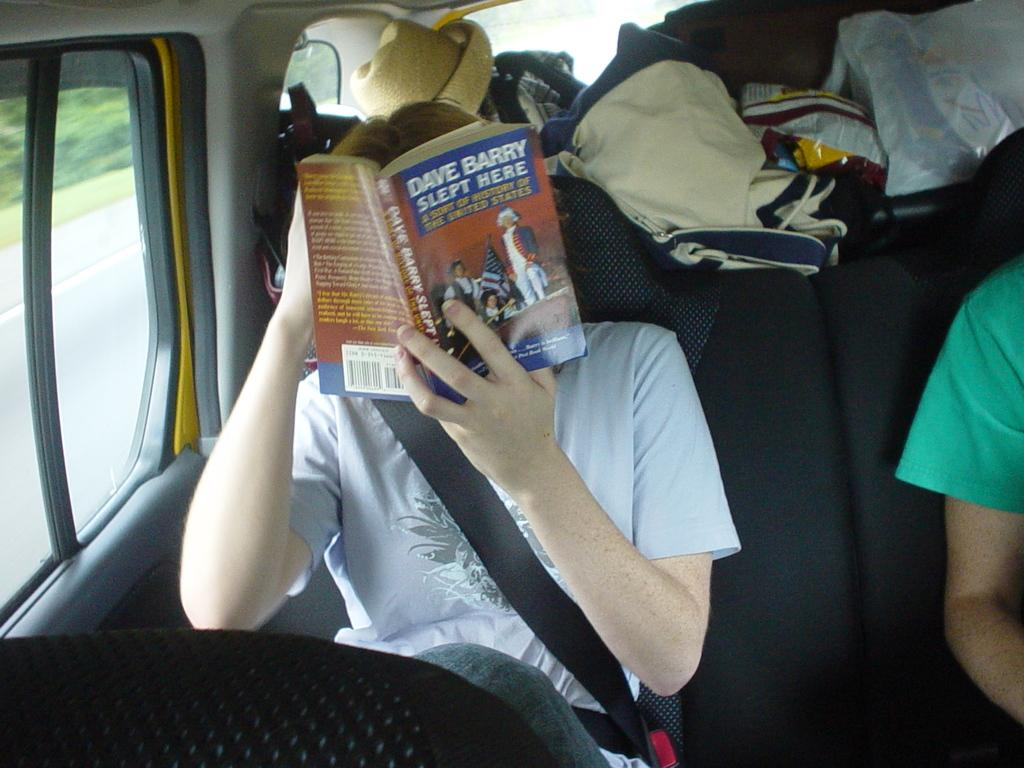<image>
Give a short and clear explanation of the subsequent image. A boy with a book in front of his face titled Dave Barry slept here. 